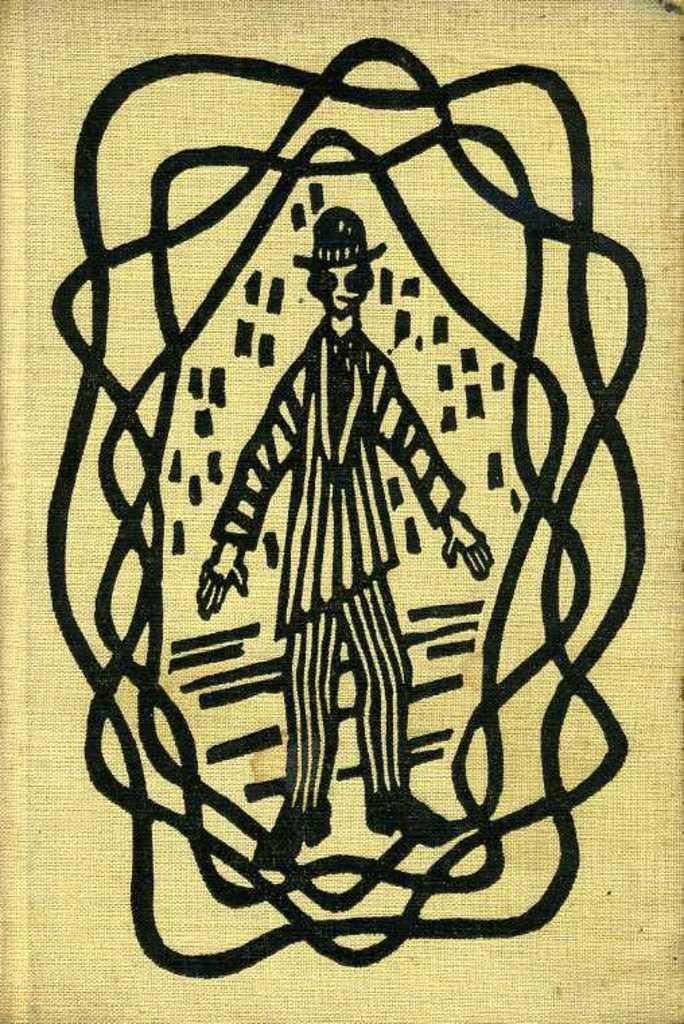What is depicted in the image? There is a drawing of a person in the image. Can you describe the person in the drawing? The provided facts do not include a description of the person in the drawing. What is the medium of the drawing? The medium of the drawing is not mentioned in the provided facts. What type of plantation can be seen in the background of the drawing? There is no mention of a plantation or any background details in the provided facts. 